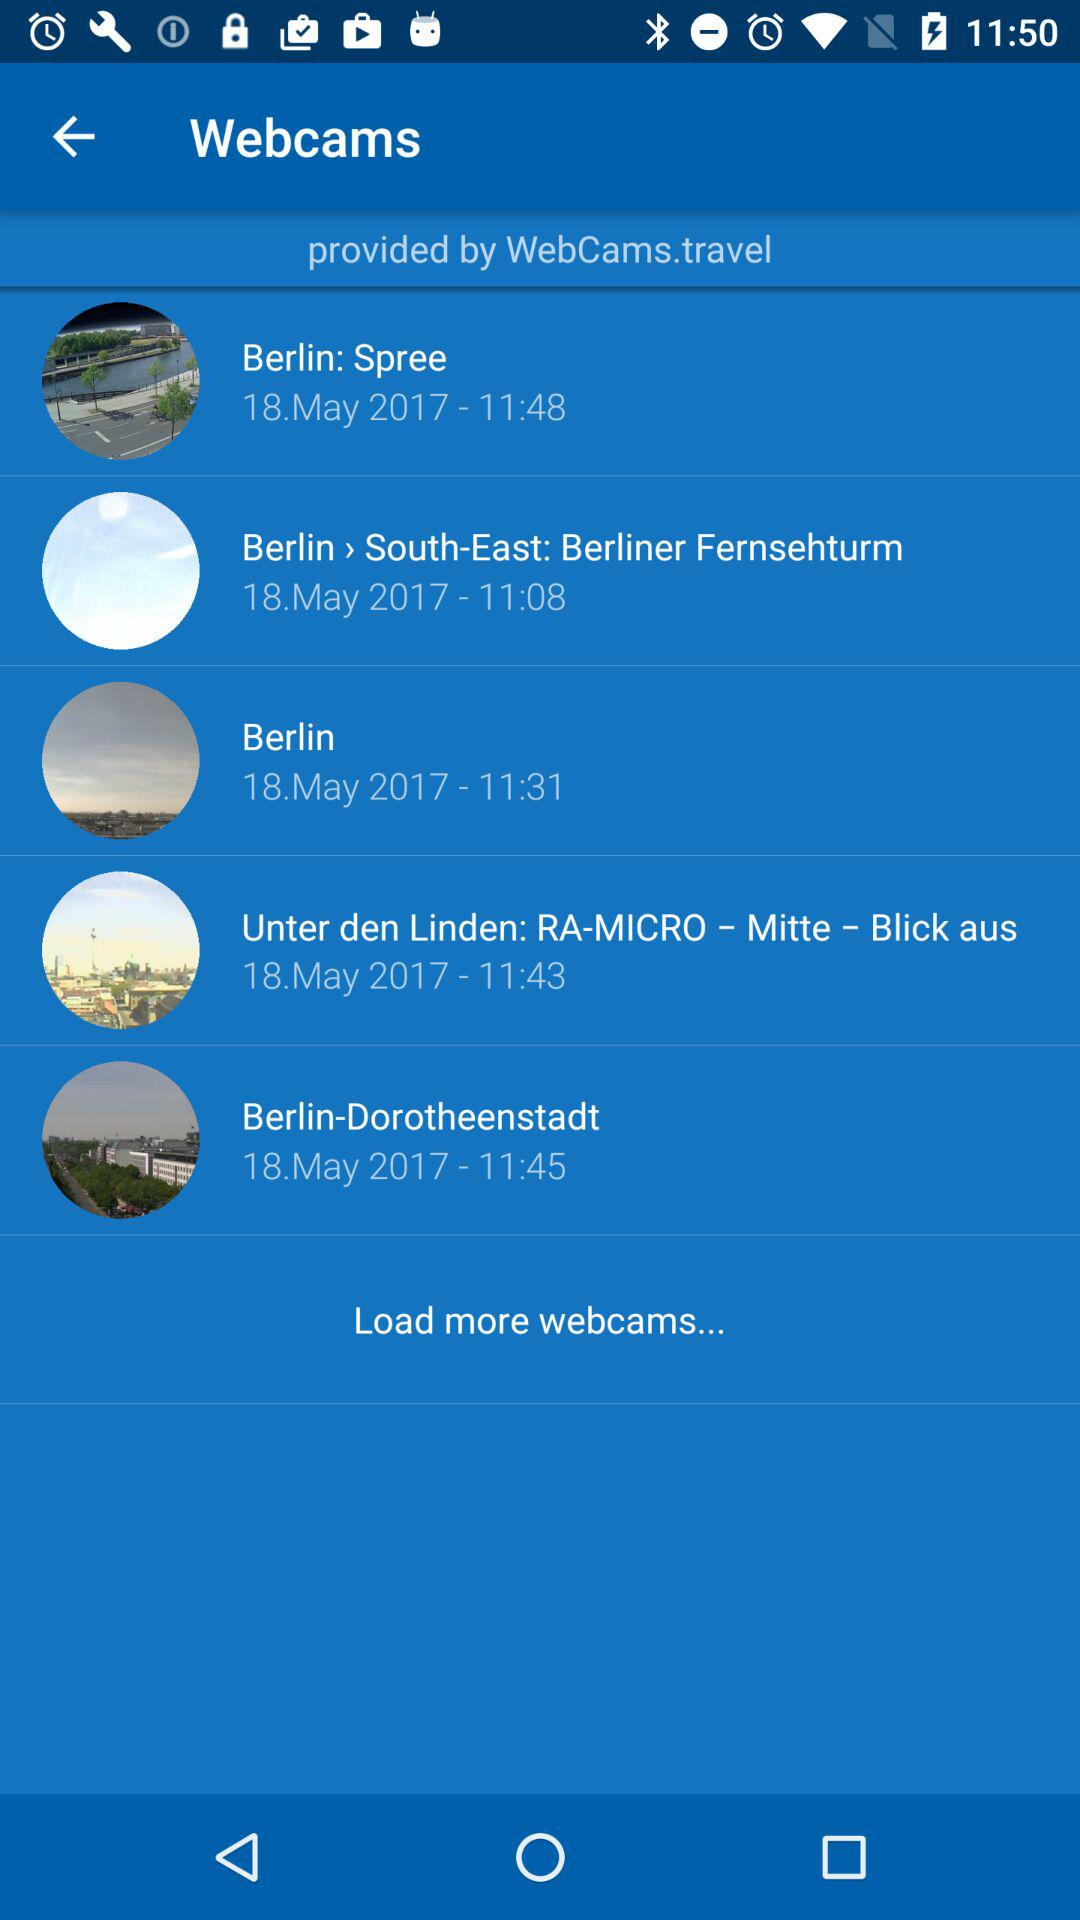What is the date of "Berlin: Spree"? The date is May 18, 2017. 